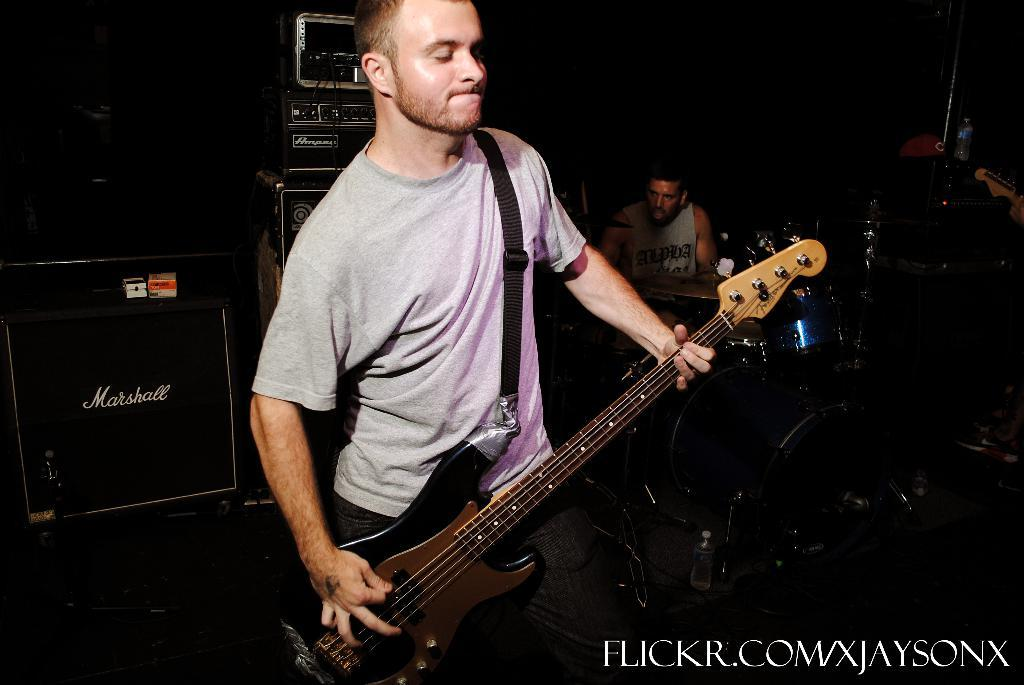What are the people in the image doing? The people in the image are playing musical instruments. What is the purpose of the mailbox in the image? There is no mailbox present in the image. Can you describe the sail on the boat in the image? There is no boat or sail present in the image. 